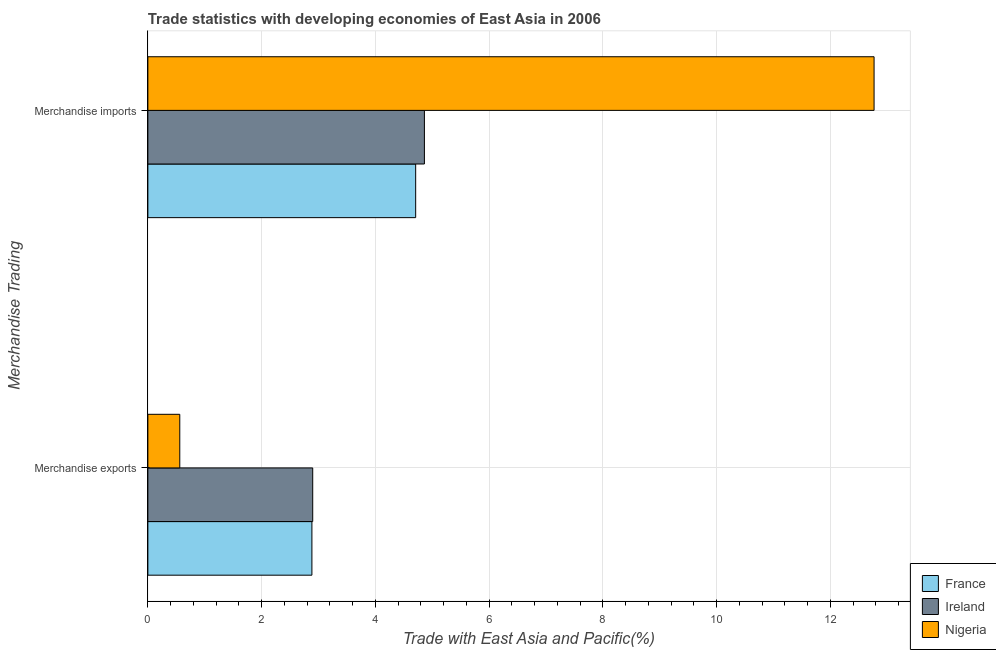How many different coloured bars are there?
Your answer should be compact. 3. What is the label of the 2nd group of bars from the top?
Make the answer very short. Merchandise exports. What is the merchandise exports in Nigeria?
Offer a very short reply. 0.56. Across all countries, what is the maximum merchandise exports?
Ensure brevity in your answer.  2.9. Across all countries, what is the minimum merchandise imports?
Offer a terse response. 4.71. In which country was the merchandise exports maximum?
Provide a succinct answer. Ireland. In which country was the merchandise exports minimum?
Offer a very short reply. Nigeria. What is the total merchandise imports in the graph?
Your response must be concise. 22.34. What is the difference between the merchandise imports in Ireland and that in Nigeria?
Your answer should be compact. -7.9. What is the difference between the merchandise imports in France and the merchandise exports in Nigeria?
Ensure brevity in your answer.  4.15. What is the average merchandise imports per country?
Offer a terse response. 7.45. What is the difference between the merchandise exports and merchandise imports in France?
Offer a very short reply. -1.82. In how many countries, is the merchandise exports greater than 9.2 %?
Your answer should be compact. 0. What is the ratio of the merchandise exports in Nigeria to that in France?
Offer a very short reply. 0.19. In how many countries, is the merchandise imports greater than the average merchandise imports taken over all countries?
Give a very brief answer. 1. What does the 1st bar from the top in Merchandise imports represents?
Give a very brief answer. Nigeria. What does the 2nd bar from the bottom in Merchandise exports represents?
Offer a very short reply. Ireland. How many bars are there?
Provide a short and direct response. 6. Are all the bars in the graph horizontal?
Your answer should be compact. Yes. How many countries are there in the graph?
Offer a terse response. 3. Are the values on the major ticks of X-axis written in scientific E-notation?
Offer a very short reply. No. Does the graph contain any zero values?
Make the answer very short. No. Where does the legend appear in the graph?
Keep it short and to the point. Bottom right. What is the title of the graph?
Your response must be concise. Trade statistics with developing economies of East Asia in 2006. Does "Syrian Arab Republic" appear as one of the legend labels in the graph?
Make the answer very short. No. What is the label or title of the X-axis?
Offer a terse response. Trade with East Asia and Pacific(%). What is the label or title of the Y-axis?
Keep it short and to the point. Merchandise Trading. What is the Trade with East Asia and Pacific(%) of France in Merchandise exports?
Your response must be concise. 2.88. What is the Trade with East Asia and Pacific(%) in Ireland in Merchandise exports?
Provide a succinct answer. 2.9. What is the Trade with East Asia and Pacific(%) of Nigeria in Merchandise exports?
Provide a short and direct response. 0.56. What is the Trade with East Asia and Pacific(%) in France in Merchandise imports?
Your answer should be very brief. 4.71. What is the Trade with East Asia and Pacific(%) in Ireland in Merchandise imports?
Offer a very short reply. 4.86. What is the Trade with East Asia and Pacific(%) in Nigeria in Merchandise imports?
Make the answer very short. 12.77. Across all Merchandise Trading, what is the maximum Trade with East Asia and Pacific(%) of France?
Ensure brevity in your answer.  4.71. Across all Merchandise Trading, what is the maximum Trade with East Asia and Pacific(%) in Ireland?
Give a very brief answer. 4.86. Across all Merchandise Trading, what is the maximum Trade with East Asia and Pacific(%) in Nigeria?
Provide a short and direct response. 12.77. Across all Merchandise Trading, what is the minimum Trade with East Asia and Pacific(%) in France?
Your answer should be compact. 2.88. Across all Merchandise Trading, what is the minimum Trade with East Asia and Pacific(%) in Ireland?
Ensure brevity in your answer.  2.9. Across all Merchandise Trading, what is the minimum Trade with East Asia and Pacific(%) in Nigeria?
Offer a terse response. 0.56. What is the total Trade with East Asia and Pacific(%) in France in the graph?
Your response must be concise. 7.59. What is the total Trade with East Asia and Pacific(%) of Ireland in the graph?
Ensure brevity in your answer.  7.76. What is the total Trade with East Asia and Pacific(%) of Nigeria in the graph?
Keep it short and to the point. 13.33. What is the difference between the Trade with East Asia and Pacific(%) of France in Merchandise exports and that in Merchandise imports?
Your answer should be compact. -1.82. What is the difference between the Trade with East Asia and Pacific(%) of Ireland in Merchandise exports and that in Merchandise imports?
Ensure brevity in your answer.  -1.96. What is the difference between the Trade with East Asia and Pacific(%) of Nigeria in Merchandise exports and that in Merchandise imports?
Provide a succinct answer. -12.21. What is the difference between the Trade with East Asia and Pacific(%) of France in Merchandise exports and the Trade with East Asia and Pacific(%) of Ireland in Merchandise imports?
Your answer should be very brief. -1.98. What is the difference between the Trade with East Asia and Pacific(%) in France in Merchandise exports and the Trade with East Asia and Pacific(%) in Nigeria in Merchandise imports?
Make the answer very short. -9.88. What is the difference between the Trade with East Asia and Pacific(%) of Ireland in Merchandise exports and the Trade with East Asia and Pacific(%) of Nigeria in Merchandise imports?
Provide a short and direct response. -9.87. What is the average Trade with East Asia and Pacific(%) of France per Merchandise Trading?
Offer a very short reply. 3.8. What is the average Trade with East Asia and Pacific(%) in Ireland per Merchandise Trading?
Give a very brief answer. 3.88. What is the average Trade with East Asia and Pacific(%) of Nigeria per Merchandise Trading?
Offer a very short reply. 6.66. What is the difference between the Trade with East Asia and Pacific(%) of France and Trade with East Asia and Pacific(%) of Ireland in Merchandise exports?
Your response must be concise. -0.01. What is the difference between the Trade with East Asia and Pacific(%) in France and Trade with East Asia and Pacific(%) in Nigeria in Merchandise exports?
Make the answer very short. 2.32. What is the difference between the Trade with East Asia and Pacific(%) in Ireland and Trade with East Asia and Pacific(%) in Nigeria in Merchandise exports?
Your response must be concise. 2.34. What is the difference between the Trade with East Asia and Pacific(%) of France and Trade with East Asia and Pacific(%) of Ireland in Merchandise imports?
Ensure brevity in your answer.  -0.15. What is the difference between the Trade with East Asia and Pacific(%) of France and Trade with East Asia and Pacific(%) of Nigeria in Merchandise imports?
Make the answer very short. -8.06. What is the difference between the Trade with East Asia and Pacific(%) in Ireland and Trade with East Asia and Pacific(%) in Nigeria in Merchandise imports?
Offer a very short reply. -7.9. What is the ratio of the Trade with East Asia and Pacific(%) of France in Merchandise exports to that in Merchandise imports?
Provide a succinct answer. 0.61. What is the ratio of the Trade with East Asia and Pacific(%) of Ireland in Merchandise exports to that in Merchandise imports?
Make the answer very short. 0.6. What is the ratio of the Trade with East Asia and Pacific(%) in Nigeria in Merchandise exports to that in Merchandise imports?
Your answer should be compact. 0.04. What is the difference between the highest and the second highest Trade with East Asia and Pacific(%) of France?
Provide a short and direct response. 1.82. What is the difference between the highest and the second highest Trade with East Asia and Pacific(%) in Ireland?
Offer a terse response. 1.96. What is the difference between the highest and the second highest Trade with East Asia and Pacific(%) in Nigeria?
Your answer should be very brief. 12.21. What is the difference between the highest and the lowest Trade with East Asia and Pacific(%) of France?
Ensure brevity in your answer.  1.82. What is the difference between the highest and the lowest Trade with East Asia and Pacific(%) of Ireland?
Keep it short and to the point. 1.96. What is the difference between the highest and the lowest Trade with East Asia and Pacific(%) in Nigeria?
Keep it short and to the point. 12.21. 